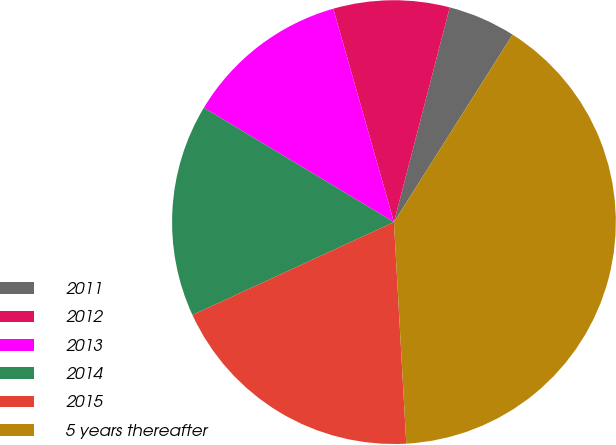Convert chart to OTSL. <chart><loc_0><loc_0><loc_500><loc_500><pie_chart><fcel>2011<fcel>2012<fcel>2013<fcel>2014<fcel>2015<fcel>5 years thereafter<nl><fcel>4.93%<fcel>8.45%<fcel>11.97%<fcel>15.49%<fcel>19.01%<fcel>40.13%<nl></chart> 